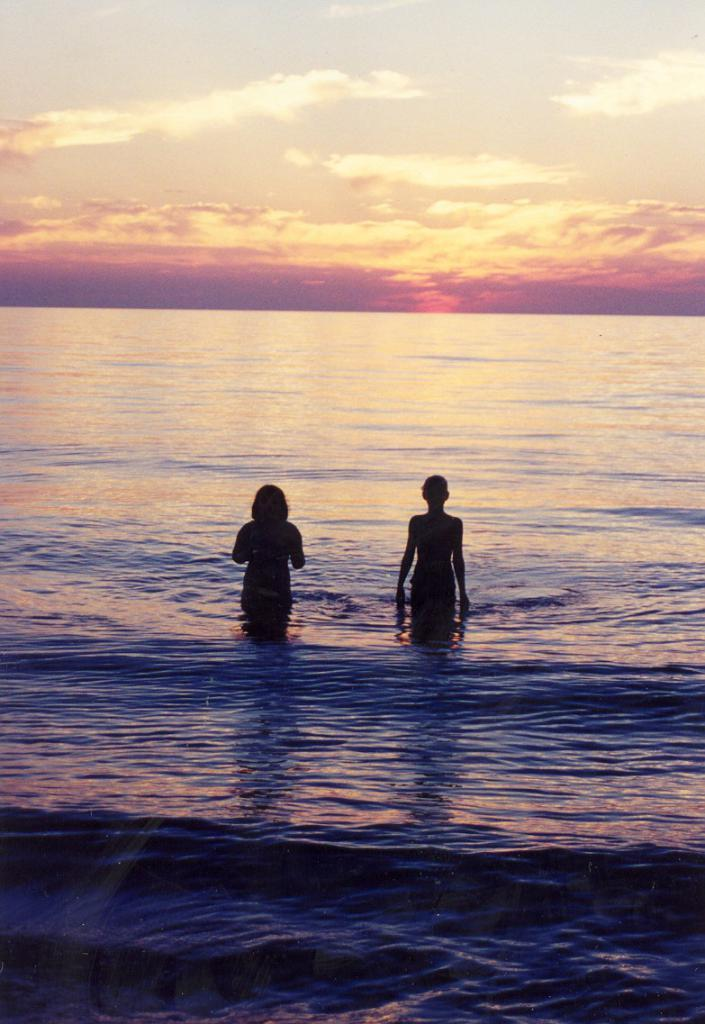How many people are in the water in the image? There are two persons standing in the water in the image. What can be seen in the background of the image? The sky is visible in the image. What colors are present in the sky? The color of the sky is orange and white. What type of rat can be seen climbing the person's leg in the image? There is no rat present in the image; it only features two persons standing in the water. 